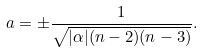<formula> <loc_0><loc_0><loc_500><loc_500>a = \pm \frac { 1 } { \sqrt { | \alpha | ( n - 2 ) ( n - 3 ) } } .</formula> 